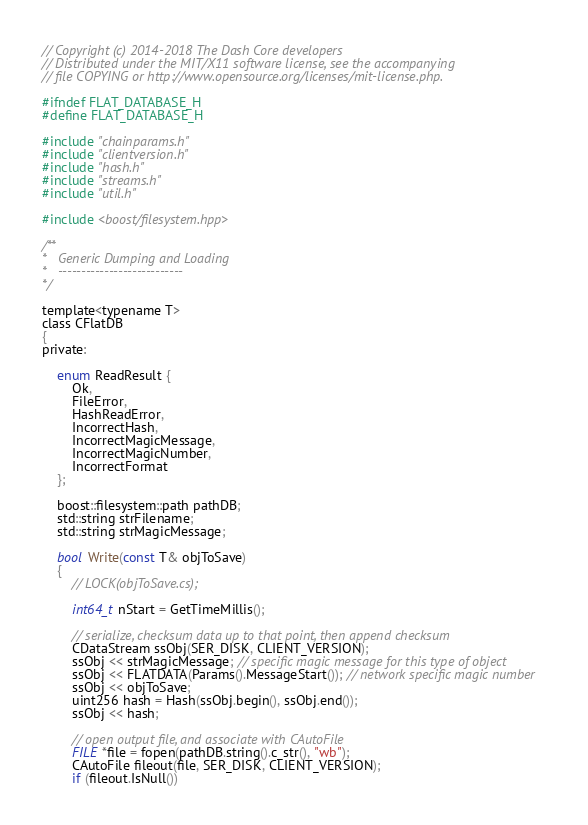Convert code to text. <code><loc_0><loc_0><loc_500><loc_500><_C_>// Copyright (c) 2014-2018 The Dash Core developers
// Distributed under the MIT/X11 software license, see the accompanying
// file COPYING or http://www.opensource.org/licenses/mit-license.php.

#ifndef FLAT_DATABASE_H
#define FLAT_DATABASE_H

#include "chainparams.h"
#include "clientversion.h"
#include "hash.h"
#include "streams.h"
#include "util.h"

#include <boost/filesystem.hpp>

/** 
*   Generic Dumping and Loading
*   ---------------------------
*/

template<typename T>
class CFlatDB
{
private:

    enum ReadResult {
        Ok,
        FileError,
        HashReadError,
        IncorrectHash,
        IncorrectMagicMessage,
        IncorrectMagicNumber,
        IncorrectFormat
    };

    boost::filesystem::path pathDB;
    std::string strFilename;
    std::string strMagicMessage;

    bool Write(const T& objToSave)
    {
        // LOCK(objToSave.cs);

        int64_t nStart = GetTimeMillis();

        // serialize, checksum data up to that point, then append checksum
        CDataStream ssObj(SER_DISK, CLIENT_VERSION);
        ssObj << strMagicMessage; // specific magic message for this type of object
        ssObj << FLATDATA(Params().MessageStart()); // network specific magic number
        ssObj << objToSave;
        uint256 hash = Hash(ssObj.begin(), ssObj.end());
        ssObj << hash;

        // open output file, and associate with CAutoFile
        FILE *file = fopen(pathDB.string().c_str(), "wb");
        CAutoFile fileout(file, SER_DISK, CLIENT_VERSION);
        if (fileout.IsNull())</code> 